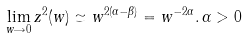Convert formula to latex. <formula><loc_0><loc_0><loc_500><loc_500>\lim _ { w \rightarrow 0 } z ^ { 2 } ( w ) \simeq w ^ { 2 ( \alpha - \beta ) } = w ^ { - 2 \alpha } . \, \alpha > 0</formula> 